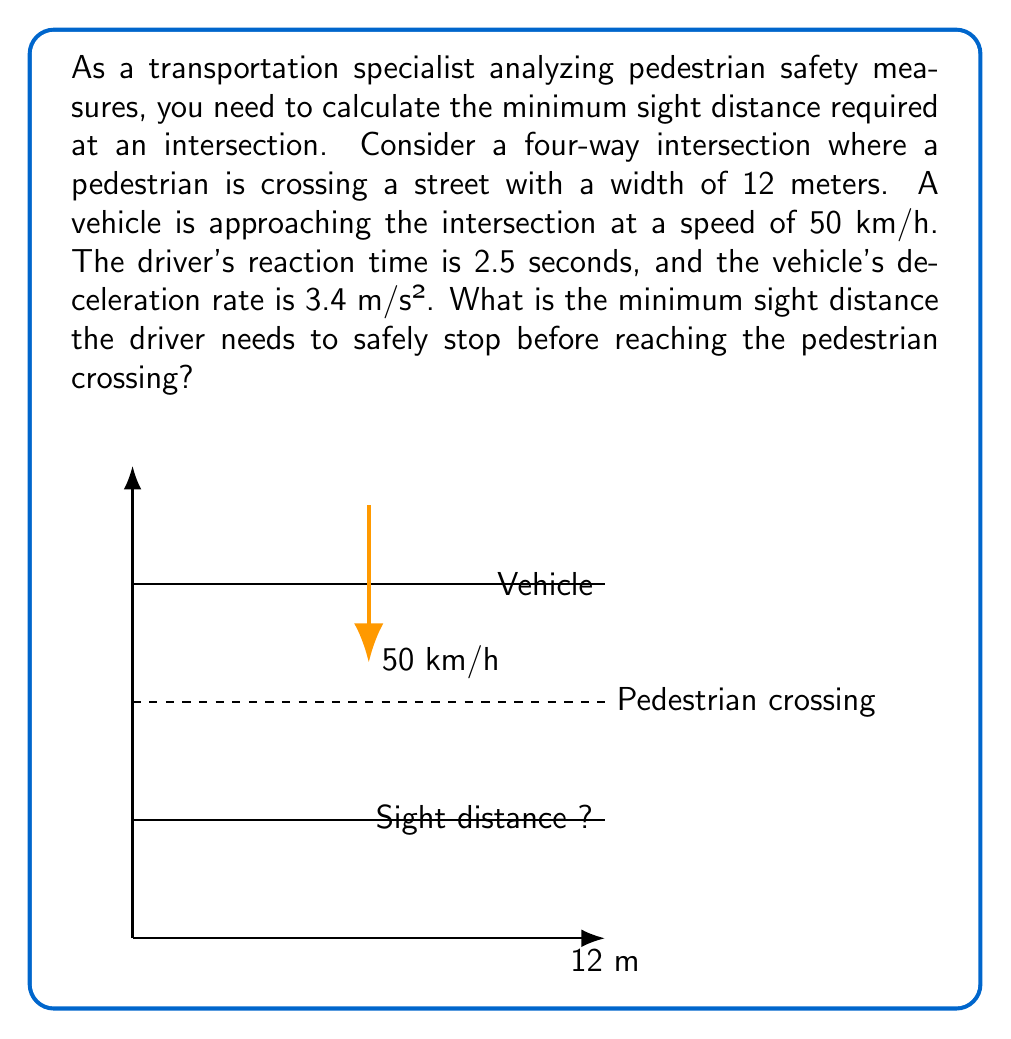What is the answer to this math problem? To calculate the minimum sight distance, we need to consider both the distance traveled during the driver's reaction time and the braking distance. Let's break this down step-by-step:

1. Convert the vehicle speed from km/h to m/s:
   $$ 50 \frac{km}{h} \times \frac{1000 m}{1 km} \times \frac{1 h}{3600 s} = 13.89 \frac{m}{s} $$

2. Calculate the distance traveled during the reaction time:
   $$ d_{reaction} = v \times t = 13.89 \frac{m}{s} \times 2.5 s = 34.72 m $$

3. Calculate the braking distance using the kinematic equation:
   $$ v^2 = u^2 + 2as $$
   Where $v$ is the final velocity (0 m/s), $u$ is the initial velocity (13.89 m/s), $a$ is the deceleration (-3.4 m/s²), and $s$ is the braking distance.
   
   $$ 0^2 = 13.89^2 + 2(-3.4)s $$
   $$ s = \frac{13.89^2}{2 \times 3.4} = 28.37 m $$

4. The total sight distance is the sum of the reaction distance and braking distance:
   $$ d_{total} = d_{reaction} + d_{braking} = 34.72 m + 28.37 m = 63.09 m $$

5. Round up to the nearest meter for safety:
   $$ d_{total} \approx 64 m $$
Answer: 64 m 